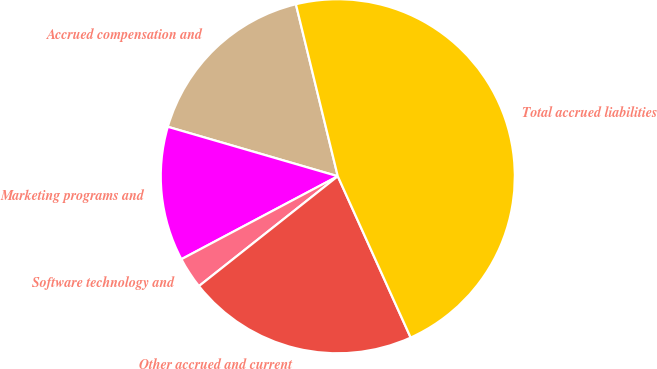Convert chart to OTSL. <chart><loc_0><loc_0><loc_500><loc_500><pie_chart><fcel>Accrued compensation and<fcel>Marketing programs and<fcel>Software technology and<fcel>Other accrued and current<fcel>Total accrued liabilities<nl><fcel>16.69%<fcel>12.27%<fcel>2.89%<fcel>21.1%<fcel>47.05%<nl></chart> 